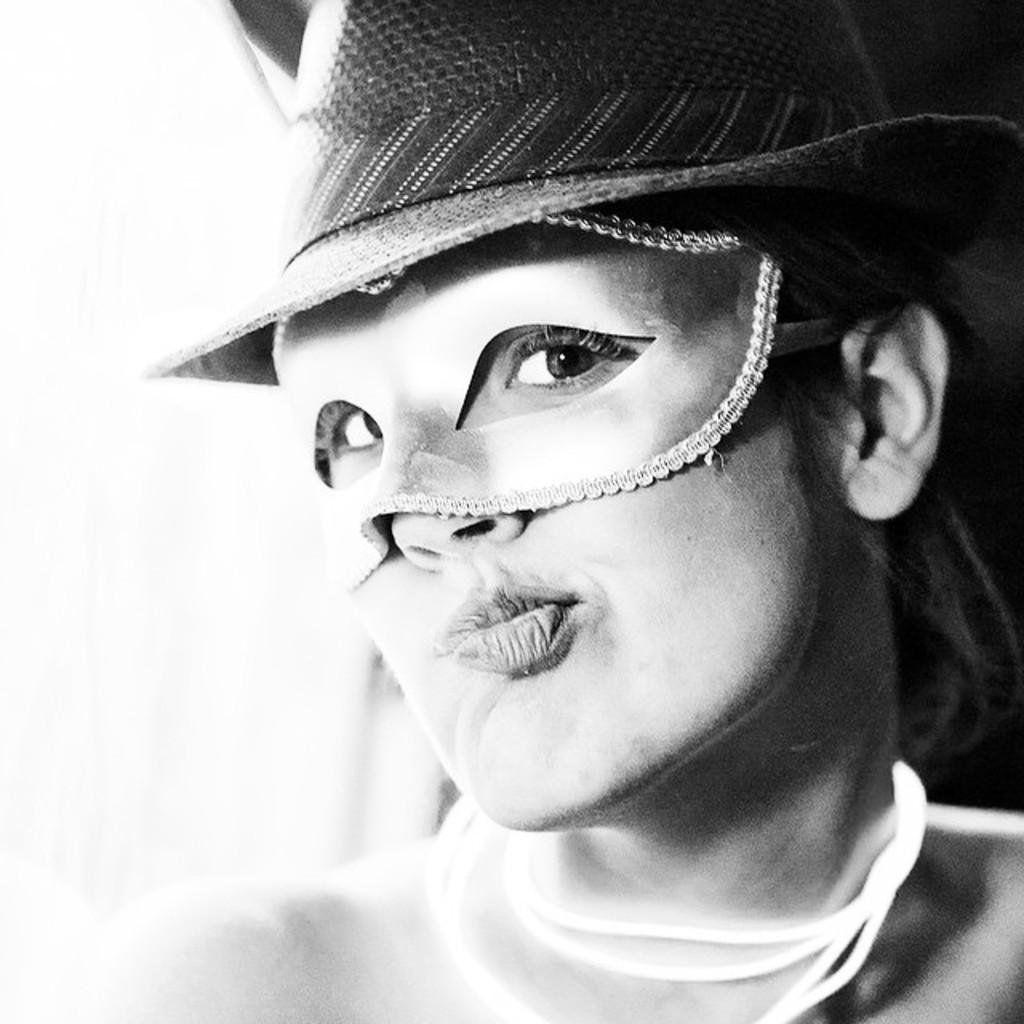Describe this image in one or two sentences. This is a black and white pic. We can see a mask to the eyes of a woman and there is a hat on her head. 